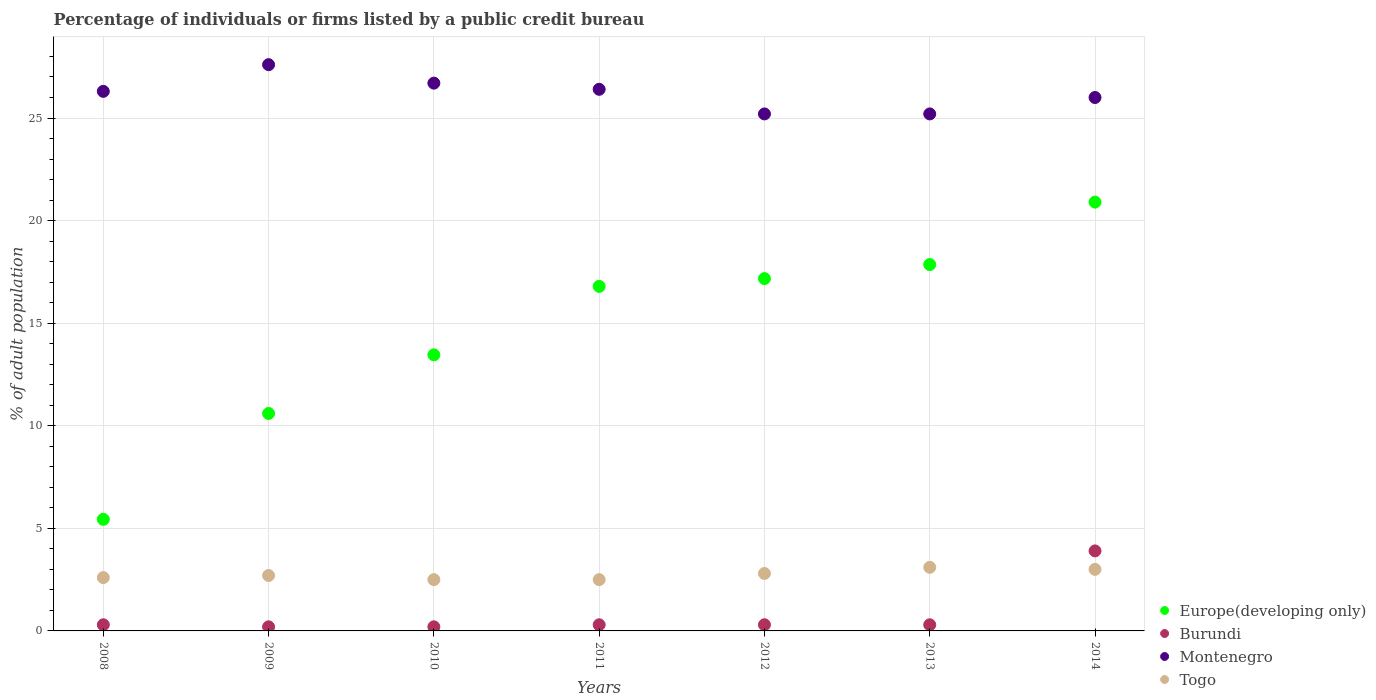How many different coloured dotlines are there?
Your answer should be compact. 4. Is the number of dotlines equal to the number of legend labels?
Your response must be concise. Yes. What is the percentage of population listed by a public credit bureau in Europe(developing only) in 2012?
Offer a very short reply. 17.17. Across all years, what is the maximum percentage of population listed by a public credit bureau in Montenegro?
Offer a very short reply. 27.6. In which year was the percentage of population listed by a public credit bureau in Togo maximum?
Make the answer very short. 2013. In which year was the percentage of population listed by a public credit bureau in Montenegro minimum?
Offer a terse response. 2012. What is the total percentage of population listed by a public credit bureau in Europe(developing only) in the graph?
Your response must be concise. 102.22. What is the difference between the percentage of population listed by a public credit bureau in Europe(developing only) in 2010 and that in 2011?
Your answer should be compact. -3.34. What is the average percentage of population listed by a public credit bureau in Europe(developing only) per year?
Ensure brevity in your answer.  14.6. In the year 2010, what is the difference between the percentage of population listed by a public credit bureau in Togo and percentage of population listed by a public credit bureau in Europe(developing only)?
Give a very brief answer. -10.96. In how many years, is the percentage of population listed by a public credit bureau in Togo greater than 21 %?
Make the answer very short. 0. What is the ratio of the percentage of population listed by a public credit bureau in Burundi in 2009 to that in 2011?
Offer a very short reply. 0.67. Is the percentage of population listed by a public credit bureau in Togo in 2012 less than that in 2014?
Your answer should be compact. Yes. What is the difference between the highest and the second highest percentage of population listed by a public credit bureau in Togo?
Offer a very short reply. 0.1. What is the difference between the highest and the lowest percentage of population listed by a public credit bureau in Burundi?
Offer a terse response. 3.7. Is it the case that in every year, the sum of the percentage of population listed by a public credit bureau in Togo and percentage of population listed by a public credit bureau in Europe(developing only)  is greater than the percentage of population listed by a public credit bureau in Montenegro?
Ensure brevity in your answer.  No. Does the percentage of population listed by a public credit bureau in Europe(developing only) monotonically increase over the years?
Your answer should be compact. Yes. How many dotlines are there?
Offer a very short reply. 4. What is the difference between two consecutive major ticks on the Y-axis?
Give a very brief answer. 5. Where does the legend appear in the graph?
Offer a very short reply. Bottom right. How many legend labels are there?
Keep it short and to the point. 4. How are the legend labels stacked?
Your answer should be very brief. Vertical. What is the title of the graph?
Your answer should be compact. Percentage of individuals or firms listed by a public credit bureau. Does "Micronesia" appear as one of the legend labels in the graph?
Your response must be concise. No. What is the label or title of the Y-axis?
Make the answer very short. % of adult population. What is the % of adult population of Europe(developing only) in 2008?
Your answer should be compact. 5.44. What is the % of adult population of Montenegro in 2008?
Your answer should be compact. 26.3. What is the % of adult population of Europe(developing only) in 2009?
Give a very brief answer. 10.6. What is the % of adult population of Montenegro in 2009?
Keep it short and to the point. 27.6. What is the % of adult population in Europe(developing only) in 2010?
Offer a very short reply. 13.46. What is the % of adult population of Montenegro in 2010?
Offer a very short reply. 26.7. What is the % of adult population of Togo in 2010?
Ensure brevity in your answer.  2.5. What is the % of adult population of Europe(developing only) in 2011?
Your answer should be very brief. 16.79. What is the % of adult population in Montenegro in 2011?
Give a very brief answer. 26.4. What is the % of adult population of Europe(developing only) in 2012?
Give a very brief answer. 17.17. What is the % of adult population in Burundi in 2012?
Your answer should be very brief. 0.3. What is the % of adult population of Montenegro in 2012?
Give a very brief answer. 25.2. What is the % of adult population in Europe(developing only) in 2013?
Offer a terse response. 17.86. What is the % of adult population of Montenegro in 2013?
Your answer should be very brief. 25.2. What is the % of adult population in Europe(developing only) in 2014?
Your response must be concise. 20.9. What is the % of adult population of Burundi in 2014?
Your answer should be compact. 3.9. Across all years, what is the maximum % of adult population of Europe(developing only)?
Provide a short and direct response. 20.9. Across all years, what is the maximum % of adult population in Montenegro?
Provide a succinct answer. 27.6. Across all years, what is the minimum % of adult population in Europe(developing only)?
Give a very brief answer. 5.44. Across all years, what is the minimum % of adult population in Montenegro?
Keep it short and to the point. 25.2. Across all years, what is the minimum % of adult population of Togo?
Your answer should be compact. 2.5. What is the total % of adult population of Europe(developing only) in the graph?
Ensure brevity in your answer.  102.22. What is the total % of adult population of Burundi in the graph?
Make the answer very short. 5.5. What is the total % of adult population of Montenegro in the graph?
Keep it short and to the point. 183.4. What is the total % of adult population of Togo in the graph?
Offer a very short reply. 19.2. What is the difference between the % of adult population of Europe(developing only) in 2008 and that in 2009?
Your response must be concise. -5.16. What is the difference between the % of adult population of Burundi in 2008 and that in 2009?
Provide a short and direct response. 0.1. What is the difference between the % of adult population of Europe(developing only) in 2008 and that in 2010?
Ensure brevity in your answer.  -8.02. What is the difference between the % of adult population in Burundi in 2008 and that in 2010?
Offer a terse response. 0.1. What is the difference between the % of adult population of Europe(developing only) in 2008 and that in 2011?
Offer a very short reply. -11.36. What is the difference between the % of adult population in Burundi in 2008 and that in 2011?
Ensure brevity in your answer.  0. What is the difference between the % of adult population of Montenegro in 2008 and that in 2011?
Give a very brief answer. -0.1. What is the difference between the % of adult population in Europe(developing only) in 2008 and that in 2012?
Make the answer very short. -11.73. What is the difference between the % of adult population in Montenegro in 2008 and that in 2012?
Offer a terse response. 1.1. What is the difference between the % of adult population in Europe(developing only) in 2008 and that in 2013?
Your answer should be compact. -12.42. What is the difference between the % of adult population of Montenegro in 2008 and that in 2013?
Offer a terse response. 1.1. What is the difference between the % of adult population of Europe(developing only) in 2008 and that in 2014?
Ensure brevity in your answer.  -15.46. What is the difference between the % of adult population of Montenegro in 2008 and that in 2014?
Your answer should be compact. 0.3. What is the difference between the % of adult population of Europe(developing only) in 2009 and that in 2010?
Your answer should be very brief. -2.86. What is the difference between the % of adult population in Burundi in 2009 and that in 2010?
Your answer should be compact. 0. What is the difference between the % of adult population of Togo in 2009 and that in 2010?
Keep it short and to the point. 0.2. What is the difference between the % of adult population in Europe(developing only) in 2009 and that in 2011?
Provide a short and direct response. -6.19. What is the difference between the % of adult population in Burundi in 2009 and that in 2011?
Keep it short and to the point. -0.1. What is the difference between the % of adult population of Togo in 2009 and that in 2011?
Give a very brief answer. 0.2. What is the difference between the % of adult population in Europe(developing only) in 2009 and that in 2012?
Offer a terse response. -6.57. What is the difference between the % of adult population in Europe(developing only) in 2009 and that in 2013?
Provide a succinct answer. -7.26. What is the difference between the % of adult population in Togo in 2009 and that in 2013?
Keep it short and to the point. -0.4. What is the difference between the % of adult population in Europe(developing only) in 2009 and that in 2014?
Offer a very short reply. -10.3. What is the difference between the % of adult population of Burundi in 2009 and that in 2014?
Offer a very short reply. -3.7. What is the difference between the % of adult population of Montenegro in 2009 and that in 2014?
Your response must be concise. 1.6. What is the difference between the % of adult population of Togo in 2009 and that in 2014?
Give a very brief answer. -0.3. What is the difference between the % of adult population in Europe(developing only) in 2010 and that in 2011?
Your response must be concise. -3.34. What is the difference between the % of adult population in Burundi in 2010 and that in 2011?
Give a very brief answer. -0.1. What is the difference between the % of adult population in Montenegro in 2010 and that in 2011?
Offer a terse response. 0.3. What is the difference between the % of adult population of Europe(developing only) in 2010 and that in 2012?
Provide a succinct answer. -3.72. What is the difference between the % of adult population of Burundi in 2010 and that in 2012?
Your response must be concise. -0.1. What is the difference between the % of adult population in Togo in 2010 and that in 2012?
Ensure brevity in your answer.  -0.3. What is the difference between the % of adult population of Togo in 2010 and that in 2013?
Your answer should be compact. -0.6. What is the difference between the % of adult population of Europe(developing only) in 2010 and that in 2014?
Your response must be concise. -7.44. What is the difference between the % of adult population of Togo in 2010 and that in 2014?
Your answer should be compact. -0.5. What is the difference between the % of adult population of Europe(developing only) in 2011 and that in 2012?
Keep it short and to the point. -0.38. What is the difference between the % of adult population of Montenegro in 2011 and that in 2012?
Keep it short and to the point. 1.2. What is the difference between the % of adult population in Togo in 2011 and that in 2012?
Provide a succinct answer. -0.3. What is the difference between the % of adult population in Europe(developing only) in 2011 and that in 2013?
Provide a succinct answer. -1.06. What is the difference between the % of adult population of Europe(developing only) in 2011 and that in 2014?
Provide a succinct answer. -4.11. What is the difference between the % of adult population of Burundi in 2011 and that in 2014?
Make the answer very short. -3.6. What is the difference between the % of adult population of Montenegro in 2011 and that in 2014?
Offer a very short reply. 0.4. What is the difference between the % of adult population in Europe(developing only) in 2012 and that in 2013?
Your answer should be very brief. -0.68. What is the difference between the % of adult population in Burundi in 2012 and that in 2013?
Your answer should be very brief. 0. What is the difference between the % of adult population in Montenegro in 2012 and that in 2013?
Make the answer very short. 0. What is the difference between the % of adult population in Togo in 2012 and that in 2013?
Make the answer very short. -0.3. What is the difference between the % of adult population of Europe(developing only) in 2012 and that in 2014?
Provide a short and direct response. -3.73. What is the difference between the % of adult population of Europe(developing only) in 2013 and that in 2014?
Your answer should be very brief. -3.04. What is the difference between the % of adult population in Montenegro in 2013 and that in 2014?
Offer a very short reply. -0.8. What is the difference between the % of adult population in Togo in 2013 and that in 2014?
Make the answer very short. 0.1. What is the difference between the % of adult population of Europe(developing only) in 2008 and the % of adult population of Burundi in 2009?
Make the answer very short. 5.24. What is the difference between the % of adult population in Europe(developing only) in 2008 and the % of adult population in Montenegro in 2009?
Provide a succinct answer. -22.16. What is the difference between the % of adult population of Europe(developing only) in 2008 and the % of adult population of Togo in 2009?
Your answer should be very brief. 2.74. What is the difference between the % of adult population in Burundi in 2008 and the % of adult population in Montenegro in 2009?
Keep it short and to the point. -27.3. What is the difference between the % of adult population in Burundi in 2008 and the % of adult population in Togo in 2009?
Provide a succinct answer. -2.4. What is the difference between the % of adult population of Montenegro in 2008 and the % of adult population of Togo in 2009?
Your answer should be compact. 23.6. What is the difference between the % of adult population in Europe(developing only) in 2008 and the % of adult population in Burundi in 2010?
Keep it short and to the point. 5.24. What is the difference between the % of adult population in Europe(developing only) in 2008 and the % of adult population in Montenegro in 2010?
Make the answer very short. -21.26. What is the difference between the % of adult population of Europe(developing only) in 2008 and the % of adult population of Togo in 2010?
Your response must be concise. 2.94. What is the difference between the % of adult population of Burundi in 2008 and the % of adult population of Montenegro in 2010?
Provide a short and direct response. -26.4. What is the difference between the % of adult population of Burundi in 2008 and the % of adult population of Togo in 2010?
Ensure brevity in your answer.  -2.2. What is the difference between the % of adult population in Montenegro in 2008 and the % of adult population in Togo in 2010?
Ensure brevity in your answer.  23.8. What is the difference between the % of adult population of Europe(developing only) in 2008 and the % of adult population of Burundi in 2011?
Your answer should be compact. 5.14. What is the difference between the % of adult population of Europe(developing only) in 2008 and the % of adult population of Montenegro in 2011?
Keep it short and to the point. -20.96. What is the difference between the % of adult population in Europe(developing only) in 2008 and the % of adult population in Togo in 2011?
Keep it short and to the point. 2.94. What is the difference between the % of adult population in Burundi in 2008 and the % of adult population in Montenegro in 2011?
Make the answer very short. -26.1. What is the difference between the % of adult population in Montenegro in 2008 and the % of adult population in Togo in 2011?
Provide a succinct answer. 23.8. What is the difference between the % of adult population of Europe(developing only) in 2008 and the % of adult population of Burundi in 2012?
Make the answer very short. 5.14. What is the difference between the % of adult population in Europe(developing only) in 2008 and the % of adult population in Montenegro in 2012?
Keep it short and to the point. -19.76. What is the difference between the % of adult population in Europe(developing only) in 2008 and the % of adult population in Togo in 2012?
Give a very brief answer. 2.64. What is the difference between the % of adult population of Burundi in 2008 and the % of adult population of Montenegro in 2012?
Offer a very short reply. -24.9. What is the difference between the % of adult population in Europe(developing only) in 2008 and the % of adult population in Burundi in 2013?
Provide a short and direct response. 5.14. What is the difference between the % of adult population in Europe(developing only) in 2008 and the % of adult population in Montenegro in 2013?
Provide a succinct answer. -19.76. What is the difference between the % of adult population of Europe(developing only) in 2008 and the % of adult population of Togo in 2013?
Ensure brevity in your answer.  2.34. What is the difference between the % of adult population in Burundi in 2008 and the % of adult population in Montenegro in 2013?
Make the answer very short. -24.9. What is the difference between the % of adult population of Burundi in 2008 and the % of adult population of Togo in 2013?
Your answer should be very brief. -2.8. What is the difference between the % of adult population of Montenegro in 2008 and the % of adult population of Togo in 2013?
Offer a terse response. 23.2. What is the difference between the % of adult population of Europe(developing only) in 2008 and the % of adult population of Burundi in 2014?
Make the answer very short. 1.54. What is the difference between the % of adult population in Europe(developing only) in 2008 and the % of adult population in Montenegro in 2014?
Provide a short and direct response. -20.56. What is the difference between the % of adult population in Europe(developing only) in 2008 and the % of adult population in Togo in 2014?
Your response must be concise. 2.44. What is the difference between the % of adult population in Burundi in 2008 and the % of adult population in Montenegro in 2014?
Offer a very short reply. -25.7. What is the difference between the % of adult population of Burundi in 2008 and the % of adult population of Togo in 2014?
Your answer should be very brief. -2.7. What is the difference between the % of adult population in Montenegro in 2008 and the % of adult population in Togo in 2014?
Your response must be concise. 23.3. What is the difference between the % of adult population of Europe(developing only) in 2009 and the % of adult population of Burundi in 2010?
Your answer should be compact. 10.4. What is the difference between the % of adult population of Europe(developing only) in 2009 and the % of adult population of Montenegro in 2010?
Keep it short and to the point. -16.1. What is the difference between the % of adult population in Europe(developing only) in 2009 and the % of adult population in Togo in 2010?
Ensure brevity in your answer.  8.1. What is the difference between the % of adult population in Burundi in 2009 and the % of adult population in Montenegro in 2010?
Make the answer very short. -26.5. What is the difference between the % of adult population of Montenegro in 2009 and the % of adult population of Togo in 2010?
Your answer should be very brief. 25.1. What is the difference between the % of adult population of Europe(developing only) in 2009 and the % of adult population of Montenegro in 2011?
Your answer should be very brief. -15.8. What is the difference between the % of adult population in Europe(developing only) in 2009 and the % of adult population in Togo in 2011?
Keep it short and to the point. 8.1. What is the difference between the % of adult population in Burundi in 2009 and the % of adult population in Montenegro in 2011?
Ensure brevity in your answer.  -26.2. What is the difference between the % of adult population of Montenegro in 2009 and the % of adult population of Togo in 2011?
Provide a short and direct response. 25.1. What is the difference between the % of adult population in Europe(developing only) in 2009 and the % of adult population in Burundi in 2012?
Your answer should be compact. 10.3. What is the difference between the % of adult population of Europe(developing only) in 2009 and the % of adult population of Montenegro in 2012?
Ensure brevity in your answer.  -14.6. What is the difference between the % of adult population of Europe(developing only) in 2009 and the % of adult population of Togo in 2012?
Offer a very short reply. 7.8. What is the difference between the % of adult population of Burundi in 2009 and the % of adult population of Montenegro in 2012?
Offer a terse response. -25. What is the difference between the % of adult population in Montenegro in 2009 and the % of adult population in Togo in 2012?
Ensure brevity in your answer.  24.8. What is the difference between the % of adult population in Europe(developing only) in 2009 and the % of adult population in Burundi in 2013?
Provide a succinct answer. 10.3. What is the difference between the % of adult population in Europe(developing only) in 2009 and the % of adult population in Montenegro in 2013?
Ensure brevity in your answer.  -14.6. What is the difference between the % of adult population in Burundi in 2009 and the % of adult population in Togo in 2013?
Provide a succinct answer. -2.9. What is the difference between the % of adult population in Europe(developing only) in 2009 and the % of adult population in Burundi in 2014?
Offer a very short reply. 6.7. What is the difference between the % of adult population of Europe(developing only) in 2009 and the % of adult population of Montenegro in 2014?
Offer a very short reply. -15.4. What is the difference between the % of adult population in Burundi in 2009 and the % of adult population in Montenegro in 2014?
Give a very brief answer. -25.8. What is the difference between the % of adult population in Burundi in 2009 and the % of adult population in Togo in 2014?
Provide a succinct answer. -2.8. What is the difference between the % of adult population of Montenegro in 2009 and the % of adult population of Togo in 2014?
Your response must be concise. 24.6. What is the difference between the % of adult population of Europe(developing only) in 2010 and the % of adult population of Burundi in 2011?
Provide a succinct answer. 13.16. What is the difference between the % of adult population of Europe(developing only) in 2010 and the % of adult population of Montenegro in 2011?
Provide a short and direct response. -12.94. What is the difference between the % of adult population in Europe(developing only) in 2010 and the % of adult population in Togo in 2011?
Provide a succinct answer. 10.96. What is the difference between the % of adult population in Burundi in 2010 and the % of adult population in Montenegro in 2011?
Give a very brief answer. -26.2. What is the difference between the % of adult population of Burundi in 2010 and the % of adult population of Togo in 2011?
Provide a succinct answer. -2.3. What is the difference between the % of adult population of Montenegro in 2010 and the % of adult population of Togo in 2011?
Make the answer very short. 24.2. What is the difference between the % of adult population of Europe(developing only) in 2010 and the % of adult population of Burundi in 2012?
Your answer should be very brief. 13.16. What is the difference between the % of adult population of Europe(developing only) in 2010 and the % of adult population of Montenegro in 2012?
Make the answer very short. -11.74. What is the difference between the % of adult population of Europe(developing only) in 2010 and the % of adult population of Togo in 2012?
Provide a short and direct response. 10.66. What is the difference between the % of adult population of Burundi in 2010 and the % of adult population of Montenegro in 2012?
Your response must be concise. -25. What is the difference between the % of adult population in Burundi in 2010 and the % of adult population in Togo in 2012?
Provide a succinct answer. -2.6. What is the difference between the % of adult population in Montenegro in 2010 and the % of adult population in Togo in 2012?
Offer a terse response. 23.9. What is the difference between the % of adult population of Europe(developing only) in 2010 and the % of adult population of Burundi in 2013?
Make the answer very short. 13.16. What is the difference between the % of adult population of Europe(developing only) in 2010 and the % of adult population of Montenegro in 2013?
Offer a very short reply. -11.74. What is the difference between the % of adult population of Europe(developing only) in 2010 and the % of adult population of Togo in 2013?
Your response must be concise. 10.36. What is the difference between the % of adult population of Montenegro in 2010 and the % of adult population of Togo in 2013?
Your answer should be very brief. 23.6. What is the difference between the % of adult population in Europe(developing only) in 2010 and the % of adult population in Burundi in 2014?
Ensure brevity in your answer.  9.56. What is the difference between the % of adult population of Europe(developing only) in 2010 and the % of adult population of Montenegro in 2014?
Your answer should be very brief. -12.54. What is the difference between the % of adult population of Europe(developing only) in 2010 and the % of adult population of Togo in 2014?
Keep it short and to the point. 10.46. What is the difference between the % of adult population of Burundi in 2010 and the % of adult population of Montenegro in 2014?
Provide a short and direct response. -25.8. What is the difference between the % of adult population in Burundi in 2010 and the % of adult population in Togo in 2014?
Your answer should be very brief. -2.8. What is the difference between the % of adult population of Montenegro in 2010 and the % of adult population of Togo in 2014?
Your answer should be compact. 23.7. What is the difference between the % of adult population of Europe(developing only) in 2011 and the % of adult population of Burundi in 2012?
Your answer should be very brief. 16.49. What is the difference between the % of adult population of Europe(developing only) in 2011 and the % of adult population of Montenegro in 2012?
Provide a short and direct response. -8.41. What is the difference between the % of adult population of Europe(developing only) in 2011 and the % of adult population of Togo in 2012?
Provide a succinct answer. 13.99. What is the difference between the % of adult population of Burundi in 2011 and the % of adult population of Montenegro in 2012?
Give a very brief answer. -24.9. What is the difference between the % of adult population of Montenegro in 2011 and the % of adult population of Togo in 2012?
Provide a short and direct response. 23.6. What is the difference between the % of adult population of Europe(developing only) in 2011 and the % of adult population of Burundi in 2013?
Give a very brief answer. 16.49. What is the difference between the % of adult population of Europe(developing only) in 2011 and the % of adult population of Montenegro in 2013?
Ensure brevity in your answer.  -8.41. What is the difference between the % of adult population of Europe(developing only) in 2011 and the % of adult population of Togo in 2013?
Make the answer very short. 13.69. What is the difference between the % of adult population of Burundi in 2011 and the % of adult population of Montenegro in 2013?
Ensure brevity in your answer.  -24.9. What is the difference between the % of adult population of Burundi in 2011 and the % of adult population of Togo in 2013?
Provide a short and direct response. -2.8. What is the difference between the % of adult population in Montenegro in 2011 and the % of adult population in Togo in 2013?
Your answer should be very brief. 23.3. What is the difference between the % of adult population of Europe(developing only) in 2011 and the % of adult population of Burundi in 2014?
Give a very brief answer. 12.89. What is the difference between the % of adult population of Europe(developing only) in 2011 and the % of adult population of Montenegro in 2014?
Keep it short and to the point. -9.21. What is the difference between the % of adult population in Europe(developing only) in 2011 and the % of adult population in Togo in 2014?
Your response must be concise. 13.79. What is the difference between the % of adult population in Burundi in 2011 and the % of adult population in Montenegro in 2014?
Provide a short and direct response. -25.7. What is the difference between the % of adult population of Burundi in 2011 and the % of adult population of Togo in 2014?
Keep it short and to the point. -2.7. What is the difference between the % of adult population of Montenegro in 2011 and the % of adult population of Togo in 2014?
Keep it short and to the point. 23.4. What is the difference between the % of adult population in Europe(developing only) in 2012 and the % of adult population in Burundi in 2013?
Offer a very short reply. 16.87. What is the difference between the % of adult population in Europe(developing only) in 2012 and the % of adult population in Montenegro in 2013?
Your response must be concise. -8.03. What is the difference between the % of adult population in Europe(developing only) in 2012 and the % of adult population in Togo in 2013?
Your answer should be compact. 14.07. What is the difference between the % of adult population in Burundi in 2012 and the % of adult population in Montenegro in 2013?
Offer a terse response. -24.9. What is the difference between the % of adult population of Montenegro in 2012 and the % of adult population of Togo in 2013?
Your response must be concise. 22.1. What is the difference between the % of adult population in Europe(developing only) in 2012 and the % of adult population in Burundi in 2014?
Your response must be concise. 13.27. What is the difference between the % of adult population of Europe(developing only) in 2012 and the % of adult population of Montenegro in 2014?
Your response must be concise. -8.83. What is the difference between the % of adult population in Europe(developing only) in 2012 and the % of adult population in Togo in 2014?
Offer a very short reply. 14.17. What is the difference between the % of adult population in Burundi in 2012 and the % of adult population in Montenegro in 2014?
Keep it short and to the point. -25.7. What is the difference between the % of adult population in Montenegro in 2012 and the % of adult population in Togo in 2014?
Ensure brevity in your answer.  22.2. What is the difference between the % of adult population in Europe(developing only) in 2013 and the % of adult population in Burundi in 2014?
Make the answer very short. 13.96. What is the difference between the % of adult population of Europe(developing only) in 2013 and the % of adult population of Montenegro in 2014?
Your answer should be compact. -8.14. What is the difference between the % of adult population in Europe(developing only) in 2013 and the % of adult population in Togo in 2014?
Provide a succinct answer. 14.86. What is the difference between the % of adult population of Burundi in 2013 and the % of adult population of Montenegro in 2014?
Keep it short and to the point. -25.7. What is the difference between the % of adult population of Burundi in 2013 and the % of adult population of Togo in 2014?
Provide a succinct answer. -2.7. What is the average % of adult population in Europe(developing only) per year?
Provide a short and direct response. 14.6. What is the average % of adult population in Burundi per year?
Your response must be concise. 0.79. What is the average % of adult population of Montenegro per year?
Offer a terse response. 26.2. What is the average % of adult population of Togo per year?
Your answer should be compact. 2.74. In the year 2008, what is the difference between the % of adult population in Europe(developing only) and % of adult population in Burundi?
Make the answer very short. 5.14. In the year 2008, what is the difference between the % of adult population of Europe(developing only) and % of adult population of Montenegro?
Your response must be concise. -20.86. In the year 2008, what is the difference between the % of adult population of Europe(developing only) and % of adult population of Togo?
Your answer should be compact. 2.84. In the year 2008, what is the difference between the % of adult population in Montenegro and % of adult population in Togo?
Ensure brevity in your answer.  23.7. In the year 2009, what is the difference between the % of adult population in Europe(developing only) and % of adult population in Burundi?
Ensure brevity in your answer.  10.4. In the year 2009, what is the difference between the % of adult population of Europe(developing only) and % of adult population of Montenegro?
Make the answer very short. -17. In the year 2009, what is the difference between the % of adult population in Burundi and % of adult population in Montenegro?
Give a very brief answer. -27.4. In the year 2009, what is the difference between the % of adult population of Burundi and % of adult population of Togo?
Your response must be concise. -2.5. In the year 2009, what is the difference between the % of adult population in Montenegro and % of adult population in Togo?
Keep it short and to the point. 24.9. In the year 2010, what is the difference between the % of adult population of Europe(developing only) and % of adult population of Burundi?
Ensure brevity in your answer.  13.26. In the year 2010, what is the difference between the % of adult population of Europe(developing only) and % of adult population of Montenegro?
Your answer should be compact. -13.24. In the year 2010, what is the difference between the % of adult population in Europe(developing only) and % of adult population in Togo?
Your answer should be very brief. 10.96. In the year 2010, what is the difference between the % of adult population of Burundi and % of adult population of Montenegro?
Provide a succinct answer. -26.5. In the year 2010, what is the difference between the % of adult population of Burundi and % of adult population of Togo?
Ensure brevity in your answer.  -2.3. In the year 2010, what is the difference between the % of adult population in Montenegro and % of adult population in Togo?
Ensure brevity in your answer.  24.2. In the year 2011, what is the difference between the % of adult population in Europe(developing only) and % of adult population in Burundi?
Offer a very short reply. 16.49. In the year 2011, what is the difference between the % of adult population in Europe(developing only) and % of adult population in Montenegro?
Provide a succinct answer. -9.61. In the year 2011, what is the difference between the % of adult population in Europe(developing only) and % of adult population in Togo?
Your answer should be very brief. 14.29. In the year 2011, what is the difference between the % of adult population in Burundi and % of adult population in Montenegro?
Offer a very short reply. -26.1. In the year 2011, what is the difference between the % of adult population in Montenegro and % of adult population in Togo?
Your answer should be very brief. 23.9. In the year 2012, what is the difference between the % of adult population in Europe(developing only) and % of adult population in Burundi?
Keep it short and to the point. 16.87. In the year 2012, what is the difference between the % of adult population of Europe(developing only) and % of adult population of Montenegro?
Ensure brevity in your answer.  -8.03. In the year 2012, what is the difference between the % of adult population of Europe(developing only) and % of adult population of Togo?
Provide a succinct answer. 14.37. In the year 2012, what is the difference between the % of adult population in Burundi and % of adult population in Montenegro?
Make the answer very short. -24.9. In the year 2012, what is the difference between the % of adult population of Burundi and % of adult population of Togo?
Provide a succinct answer. -2.5. In the year 2012, what is the difference between the % of adult population in Montenegro and % of adult population in Togo?
Keep it short and to the point. 22.4. In the year 2013, what is the difference between the % of adult population in Europe(developing only) and % of adult population in Burundi?
Your answer should be compact. 17.56. In the year 2013, what is the difference between the % of adult population in Europe(developing only) and % of adult population in Montenegro?
Your answer should be very brief. -7.34. In the year 2013, what is the difference between the % of adult population in Europe(developing only) and % of adult population in Togo?
Your response must be concise. 14.76. In the year 2013, what is the difference between the % of adult population in Burundi and % of adult population in Montenegro?
Give a very brief answer. -24.9. In the year 2013, what is the difference between the % of adult population of Montenegro and % of adult population of Togo?
Ensure brevity in your answer.  22.1. In the year 2014, what is the difference between the % of adult population of Europe(developing only) and % of adult population of Montenegro?
Give a very brief answer. -5.1. In the year 2014, what is the difference between the % of adult population of Europe(developing only) and % of adult population of Togo?
Your answer should be very brief. 17.9. In the year 2014, what is the difference between the % of adult population of Burundi and % of adult population of Montenegro?
Your response must be concise. -22.1. What is the ratio of the % of adult population in Europe(developing only) in 2008 to that in 2009?
Your response must be concise. 0.51. What is the ratio of the % of adult population of Montenegro in 2008 to that in 2009?
Your answer should be very brief. 0.95. What is the ratio of the % of adult population in Europe(developing only) in 2008 to that in 2010?
Keep it short and to the point. 0.4. What is the ratio of the % of adult population in Togo in 2008 to that in 2010?
Your answer should be compact. 1.04. What is the ratio of the % of adult population in Europe(developing only) in 2008 to that in 2011?
Provide a succinct answer. 0.32. What is the ratio of the % of adult population in Burundi in 2008 to that in 2011?
Give a very brief answer. 1. What is the ratio of the % of adult population of Montenegro in 2008 to that in 2011?
Your answer should be compact. 1. What is the ratio of the % of adult population of Togo in 2008 to that in 2011?
Offer a very short reply. 1.04. What is the ratio of the % of adult population in Europe(developing only) in 2008 to that in 2012?
Your answer should be very brief. 0.32. What is the ratio of the % of adult population of Burundi in 2008 to that in 2012?
Keep it short and to the point. 1. What is the ratio of the % of adult population of Montenegro in 2008 to that in 2012?
Your answer should be compact. 1.04. What is the ratio of the % of adult population of Europe(developing only) in 2008 to that in 2013?
Provide a short and direct response. 0.3. What is the ratio of the % of adult population in Burundi in 2008 to that in 2013?
Give a very brief answer. 1. What is the ratio of the % of adult population of Montenegro in 2008 to that in 2013?
Your answer should be very brief. 1.04. What is the ratio of the % of adult population in Togo in 2008 to that in 2013?
Your answer should be very brief. 0.84. What is the ratio of the % of adult population in Europe(developing only) in 2008 to that in 2014?
Provide a succinct answer. 0.26. What is the ratio of the % of adult population in Burundi in 2008 to that in 2014?
Offer a very short reply. 0.08. What is the ratio of the % of adult population in Montenegro in 2008 to that in 2014?
Your answer should be very brief. 1.01. What is the ratio of the % of adult population in Togo in 2008 to that in 2014?
Provide a short and direct response. 0.87. What is the ratio of the % of adult population of Europe(developing only) in 2009 to that in 2010?
Ensure brevity in your answer.  0.79. What is the ratio of the % of adult population in Burundi in 2009 to that in 2010?
Your answer should be very brief. 1. What is the ratio of the % of adult population of Montenegro in 2009 to that in 2010?
Make the answer very short. 1.03. What is the ratio of the % of adult population in Europe(developing only) in 2009 to that in 2011?
Your response must be concise. 0.63. What is the ratio of the % of adult population in Burundi in 2009 to that in 2011?
Your answer should be compact. 0.67. What is the ratio of the % of adult population in Montenegro in 2009 to that in 2011?
Your answer should be compact. 1.05. What is the ratio of the % of adult population of Europe(developing only) in 2009 to that in 2012?
Your response must be concise. 0.62. What is the ratio of the % of adult population of Burundi in 2009 to that in 2012?
Offer a terse response. 0.67. What is the ratio of the % of adult population of Montenegro in 2009 to that in 2012?
Provide a succinct answer. 1.1. What is the ratio of the % of adult population in Togo in 2009 to that in 2012?
Your answer should be compact. 0.96. What is the ratio of the % of adult population in Europe(developing only) in 2009 to that in 2013?
Provide a short and direct response. 0.59. What is the ratio of the % of adult population in Burundi in 2009 to that in 2013?
Provide a short and direct response. 0.67. What is the ratio of the % of adult population of Montenegro in 2009 to that in 2013?
Make the answer very short. 1.1. What is the ratio of the % of adult population of Togo in 2009 to that in 2013?
Your answer should be compact. 0.87. What is the ratio of the % of adult population in Europe(developing only) in 2009 to that in 2014?
Make the answer very short. 0.51. What is the ratio of the % of adult population in Burundi in 2009 to that in 2014?
Offer a very short reply. 0.05. What is the ratio of the % of adult population in Montenegro in 2009 to that in 2014?
Offer a terse response. 1.06. What is the ratio of the % of adult population of Togo in 2009 to that in 2014?
Provide a succinct answer. 0.9. What is the ratio of the % of adult population in Europe(developing only) in 2010 to that in 2011?
Make the answer very short. 0.8. What is the ratio of the % of adult population in Burundi in 2010 to that in 2011?
Make the answer very short. 0.67. What is the ratio of the % of adult population in Montenegro in 2010 to that in 2011?
Make the answer very short. 1.01. What is the ratio of the % of adult population of Togo in 2010 to that in 2011?
Provide a short and direct response. 1. What is the ratio of the % of adult population in Europe(developing only) in 2010 to that in 2012?
Your response must be concise. 0.78. What is the ratio of the % of adult population in Montenegro in 2010 to that in 2012?
Give a very brief answer. 1.06. What is the ratio of the % of adult population in Togo in 2010 to that in 2012?
Your response must be concise. 0.89. What is the ratio of the % of adult population of Europe(developing only) in 2010 to that in 2013?
Keep it short and to the point. 0.75. What is the ratio of the % of adult population in Montenegro in 2010 to that in 2013?
Offer a terse response. 1.06. What is the ratio of the % of adult population in Togo in 2010 to that in 2013?
Keep it short and to the point. 0.81. What is the ratio of the % of adult population of Europe(developing only) in 2010 to that in 2014?
Keep it short and to the point. 0.64. What is the ratio of the % of adult population of Burundi in 2010 to that in 2014?
Ensure brevity in your answer.  0.05. What is the ratio of the % of adult population of Montenegro in 2010 to that in 2014?
Give a very brief answer. 1.03. What is the ratio of the % of adult population in Europe(developing only) in 2011 to that in 2012?
Your response must be concise. 0.98. What is the ratio of the % of adult population of Montenegro in 2011 to that in 2012?
Keep it short and to the point. 1.05. What is the ratio of the % of adult population in Togo in 2011 to that in 2012?
Your response must be concise. 0.89. What is the ratio of the % of adult population of Europe(developing only) in 2011 to that in 2013?
Ensure brevity in your answer.  0.94. What is the ratio of the % of adult population of Burundi in 2011 to that in 2013?
Ensure brevity in your answer.  1. What is the ratio of the % of adult population in Montenegro in 2011 to that in 2013?
Give a very brief answer. 1.05. What is the ratio of the % of adult population of Togo in 2011 to that in 2013?
Offer a very short reply. 0.81. What is the ratio of the % of adult population of Europe(developing only) in 2011 to that in 2014?
Give a very brief answer. 0.8. What is the ratio of the % of adult population in Burundi in 2011 to that in 2014?
Offer a very short reply. 0.08. What is the ratio of the % of adult population in Montenegro in 2011 to that in 2014?
Provide a succinct answer. 1.02. What is the ratio of the % of adult population of Europe(developing only) in 2012 to that in 2013?
Provide a succinct answer. 0.96. What is the ratio of the % of adult population in Togo in 2012 to that in 2013?
Provide a short and direct response. 0.9. What is the ratio of the % of adult population in Europe(developing only) in 2012 to that in 2014?
Give a very brief answer. 0.82. What is the ratio of the % of adult population of Burundi in 2012 to that in 2014?
Your response must be concise. 0.08. What is the ratio of the % of adult population of Montenegro in 2012 to that in 2014?
Provide a succinct answer. 0.97. What is the ratio of the % of adult population of Europe(developing only) in 2013 to that in 2014?
Provide a succinct answer. 0.85. What is the ratio of the % of adult population of Burundi in 2013 to that in 2014?
Give a very brief answer. 0.08. What is the ratio of the % of adult population of Montenegro in 2013 to that in 2014?
Keep it short and to the point. 0.97. What is the ratio of the % of adult population in Togo in 2013 to that in 2014?
Provide a succinct answer. 1.03. What is the difference between the highest and the second highest % of adult population of Europe(developing only)?
Ensure brevity in your answer.  3.04. What is the difference between the highest and the second highest % of adult population in Montenegro?
Make the answer very short. 0.9. What is the difference between the highest and the second highest % of adult population in Togo?
Give a very brief answer. 0.1. What is the difference between the highest and the lowest % of adult population in Europe(developing only)?
Provide a succinct answer. 15.46. What is the difference between the highest and the lowest % of adult population in Burundi?
Provide a short and direct response. 3.7. 